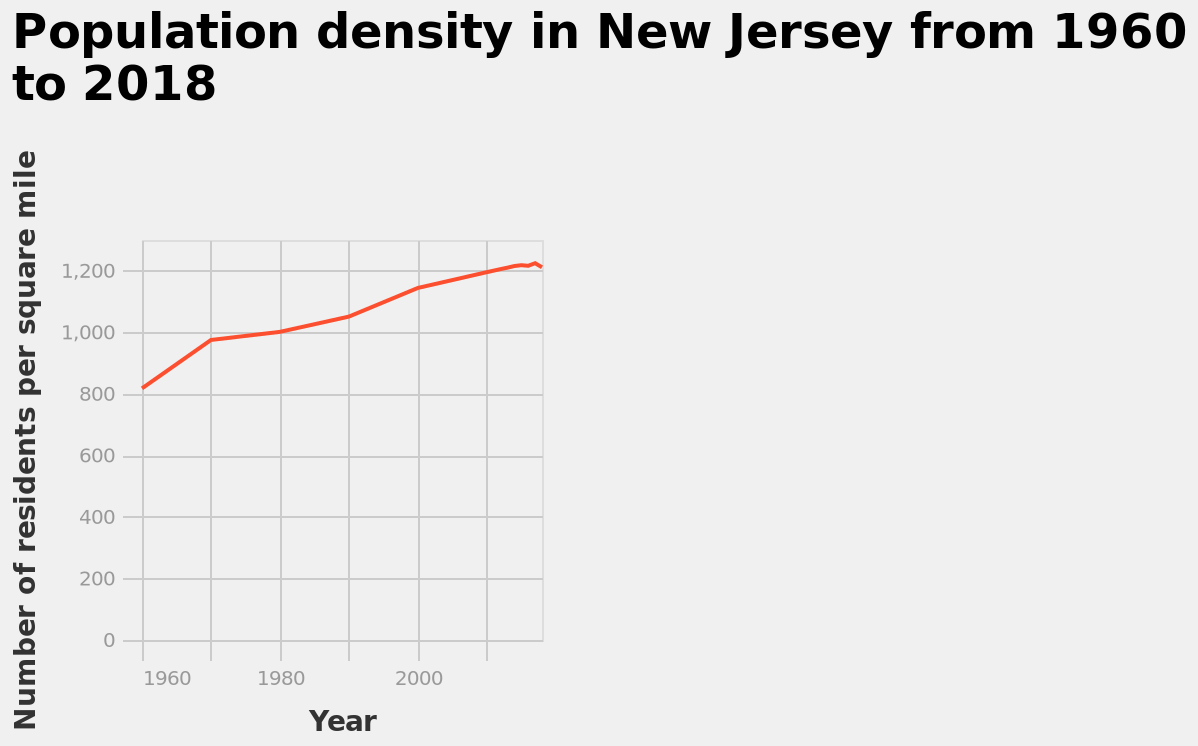<image>
What does the line chart display? The line chart displays the population density in New Jersey from 1960 to 2018, with the number of residents per square mile. please summary the statistics and relations of the chart Population density had a peak in 1960, after which it started to slow down up until 1990, when it started to increase consistently. Has the population of New Jersey been continuously increasing from 1960 to 2017? Yes, the population of New Jersey has continuously increased from 1960 to 2017. 